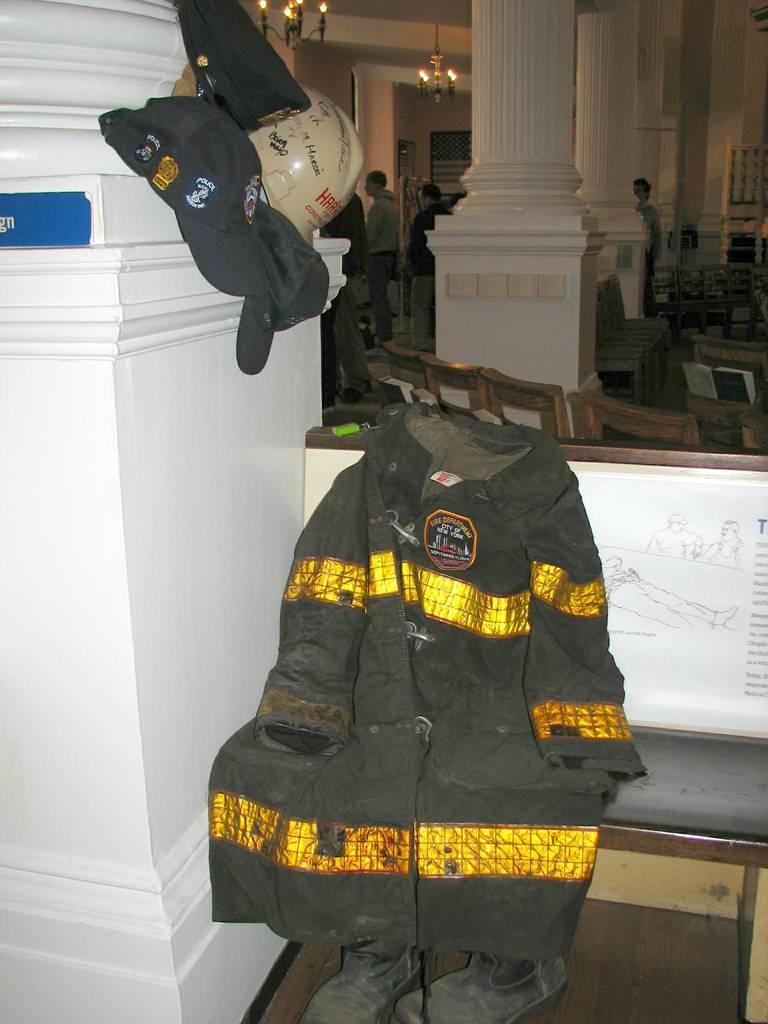Could you give a brief overview of what you see in this image? In the center of the image there is a bench. On bench we can see cloth. In the middle of the image we can see chairs. In the background of the image we can see pillars, caps, board, some persons, wall, chandeliers. At the top of the image we can see the roof. At the bottom of the image we can see shoes and floor. 